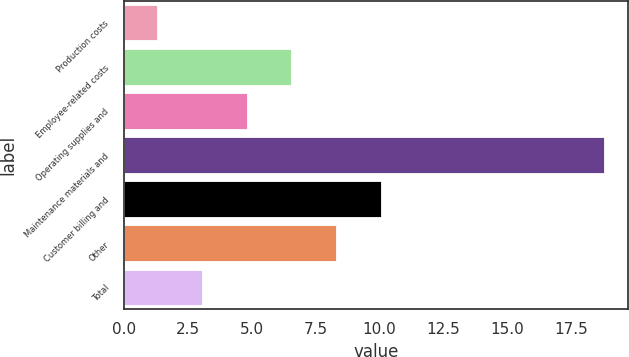<chart> <loc_0><loc_0><loc_500><loc_500><bar_chart><fcel>Production costs<fcel>Employee-related costs<fcel>Operating supplies and<fcel>Maintenance materials and<fcel>Customer billing and<fcel>Other<fcel>Total<nl><fcel>1.3<fcel>6.55<fcel>4.8<fcel>18.8<fcel>10.05<fcel>8.3<fcel>3.05<nl></chart> 